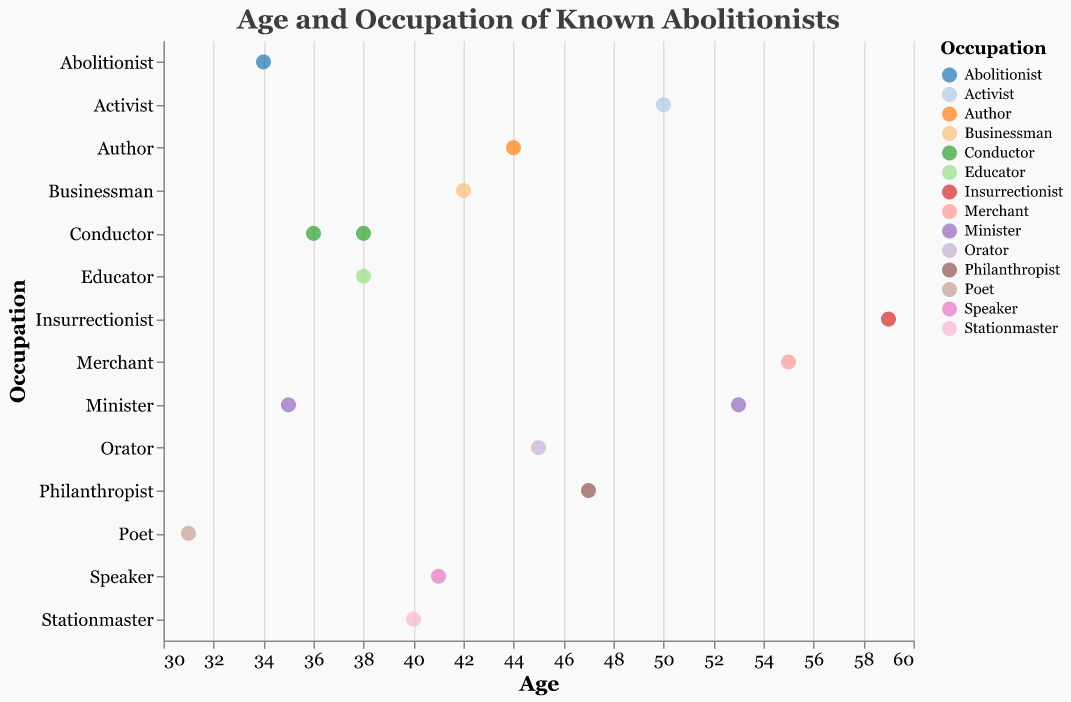What is the age of the youngest abolitionist in the plot? The scatter plot shows data points for different ages of abolitionists. The youngest age among them is 31.
Answer: 31 Which occupation is associated with the oldest abolitionist in the plot? According to the scatter plot, the oldest abolitionist is 59 years old. John Brown, who is 59, is marked as an Insurrectionist.
Answer: Insurrectionist How many abolitionists in the plot are aged 40 or above? By counting the data points with ages 40 or higher, we get: William Still, Levi Coffin, Sojourner Truth, John Rankin, Thomas Garrett, Gerrit Smith, Lydia Maria Child, Charles Burleigh, John Brown, and Frederick Douglass. This gives us a total of 10.
Answer: 10 Which occupations are represented by more than one abolitionist in the plot? Conductor (Harriet Tubman, Samuel Burris) and Minister (John Rankin, Henry Highland Garnet) each have more than one representative.
Answer: Conductor, Minister Is there a correlation between age and occupation concentration in certain age ranges? Observation of the plot shows that certain occupations such as Conductor and Educator appear in the mid-30s to late 30s. Meanwhile, titles like Insurrectionist and Minister are seen usually in the 50s age range, depicting some concentration correlates.
Answer: Mid-30s: Conductor, Educator; 50s: Insurrectionist, Minister Which abolitionist is both the youngest in their occupation and the youngest overall? Frances Ellen Watkins Harper, aged 31, is the youngest in her occupation and overall.
Answer: Frances Ellen Watkins Harper Which occupations are associated with individuals in their 50s? The scatter plot shows that abolitionists aged 50 and above include Sojourner Truth (Activist), John Rankin (Minister), Thomas Garrett (Merchant), and John Brown (Insurrectionist).
Answer: Activist, Minister, Merchant, Insurrectionist Which two abolitionists with the same occupation have the closest ages? Comparing ages of abolitionists with the same occupation, Harriet Tubman (38) and Samuel Burris (36) are both Conductors and have a close age difference of 2 years.
Answer: Harriet Tubman, Samuel Burris What is the median age of all abolitionists in the plot? To find the median age, we arrange the ages in ascending order: 31, 34, 35, 36, 38, 38, 40, 41, 42, 44, 45, 47, 50, 53, 55, 59. With 16 data points, the median will be the average of the 8th and 9th values: (41 + 42)/2 = 41.5.
Answer: 41.5 